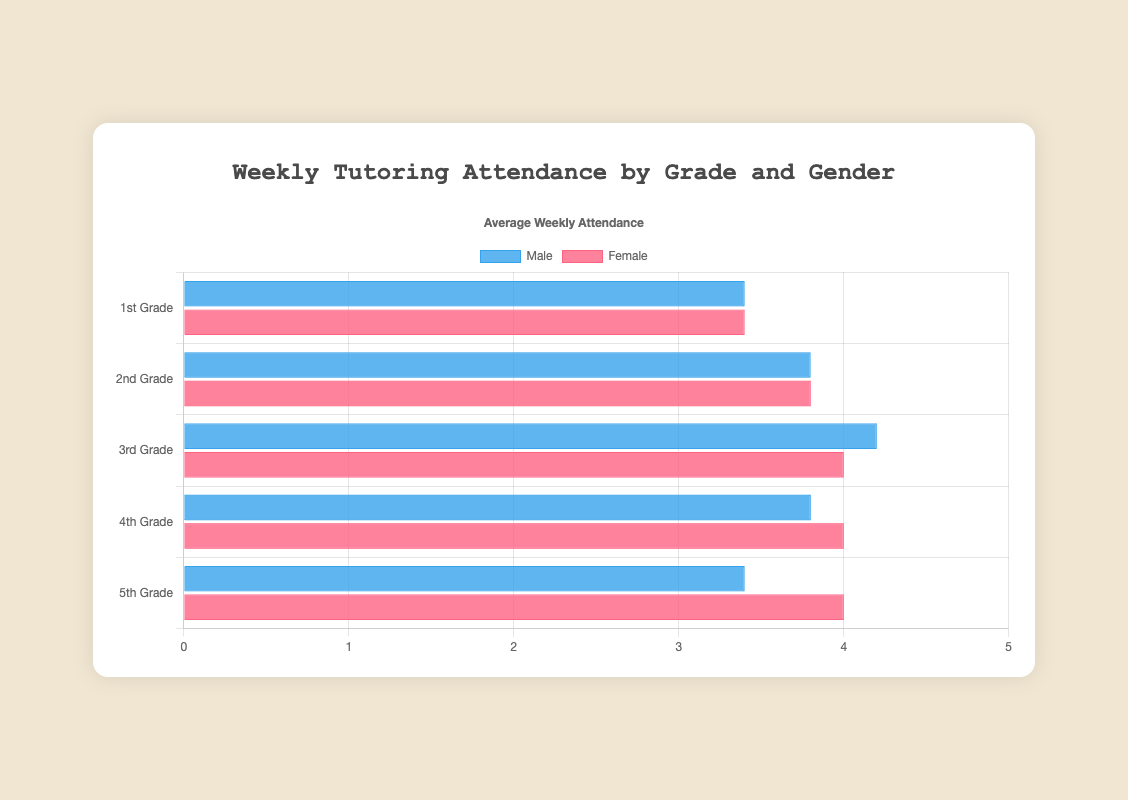Which grade level has the highest average attendance for males? To find the answer, review the heights of the blue bars for each grade level. The 3rd Grade male average attendance is the highest at 4.2.
Answer: 3rd Grade Which gender has a higher average attendance in 1st Grade? Compare the heights of the corresponding bars. The average attendance for females in 1st Grade is 3.4, while for males it is 3.4. Since both are equal, no gender has a higher attendance.
Answer: Both are equal What is the total average weekly attendance for 4th Grade students? Sum the average attendance for both genders in 4th Grade: Males (3.8) + Females (4.0) = 7.8.
Answer: 7.8 Which grade level has the greatest difference in average attendance between males and females? Calculate the difference for each grade level by subtracting the smaller average from the larger one. The largest difference is found in 2nd Grade with a difference of 0.6 (Females 3.8 - Males 3.2).
Answer: 2nd Grade How does the average attendance for 5th Grade females compare with 3rd Grade females? Compare the heights of the red bars. The average attendance for 5th Grade females is 4.0, and for 3rd Grade females, it is 4.0, so they are equal.
Answer: They are equal What is the average weekly attendance for all 2nd Grade students together? Calculate the weighted average of male and female attendances in 2nd Grade: Male (3.8) + Female (3.8) = 7.6; then average = 7.6 / 2 = 3.8.
Answer: 3.8 Which grade level has the lowest average attendance for females? Review the heights of the red bars for each grade level. The shortest bar corresponds to 1st Grade with an average attendance of 3.4.
Answer: 1st Grade What is the range of weekly attendances for males in 5th Grade? The range is the difference between the maximum and minimum values in the dataset for 5th Grade males, which are 4 and 2, respectively. 4 - 2 = 2.
Answer: 2 Which gender generally has a higher average attendance across all grades? Sum the average attendances for each gender across all grades and compare. Males: 3.4 + 3.8 + 4.2 + 3.8 + 3.4 = 18.6. Females: 3.4 + 3.8 + 4.0 + 4.0 + 4.0 = 19.2. Females generally have a higher average attendance.
Answer: Females 